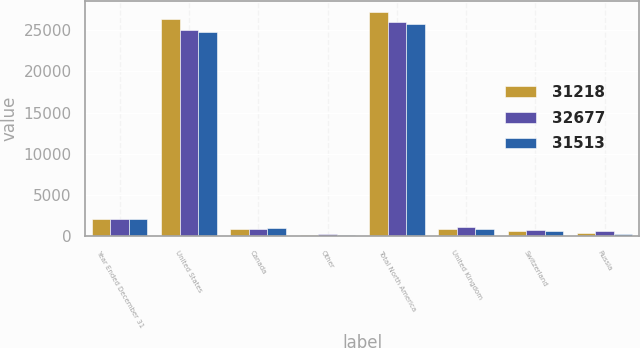Convert chart. <chart><loc_0><loc_0><loc_500><loc_500><stacked_bar_chart><ecel><fcel>Year Ended December 31<fcel>United States<fcel>Canada<fcel>Other<fcel>Total North America<fcel>United Kingdom<fcel>Switzerland<fcel>Russia<nl><fcel>31218<fcel>2011<fcel>26401<fcel>806<fcel>39<fcel>27246<fcel>857<fcel>582<fcel>287<nl><fcel>32677<fcel>2012<fcel>25004<fcel>878<fcel>165<fcel>26047<fcel>1027<fcel>679<fcel>548<nl><fcel>31513<fcel>2013<fcel>24845<fcel>923<fcel>40<fcel>25808<fcel>881<fcel>541<fcel>244<nl></chart> 